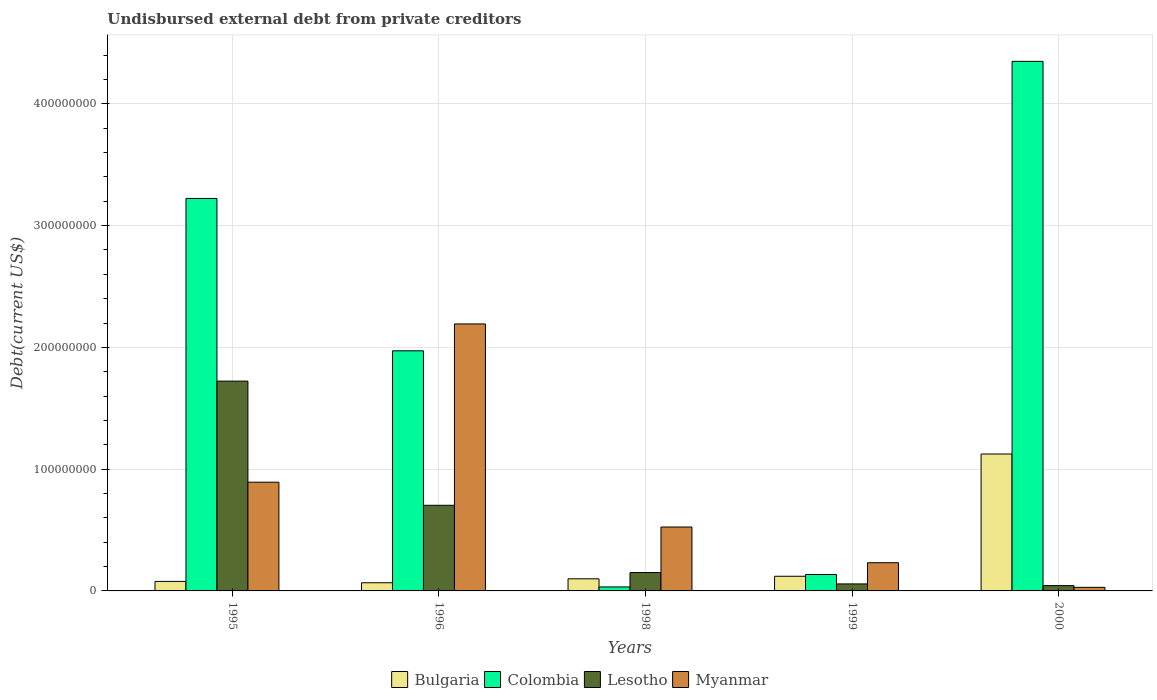How many groups of bars are there?
Your answer should be compact. 5. How many bars are there on the 3rd tick from the right?
Make the answer very short. 4. In how many cases, is the number of bars for a given year not equal to the number of legend labels?
Offer a terse response. 0. What is the total debt in Myanmar in 1996?
Offer a very short reply. 2.19e+08. Across all years, what is the maximum total debt in Bulgaria?
Offer a very short reply. 1.12e+08. Across all years, what is the minimum total debt in Bulgaria?
Ensure brevity in your answer.  6.71e+06. In which year was the total debt in Colombia maximum?
Your answer should be very brief. 2000. In which year was the total debt in Lesotho minimum?
Give a very brief answer. 2000. What is the total total debt in Myanmar in the graph?
Give a very brief answer. 3.87e+08. What is the difference between the total debt in Myanmar in 1996 and that in 1998?
Ensure brevity in your answer.  1.67e+08. What is the difference between the total debt in Lesotho in 1999 and the total debt in Colombia in 1995?
Offer a very short reply. -3.17e+08. What is the average total debt in Lesotho per year?
Your response must be concise. 5.36e+07. In the year 2000, what is the difference between the total debt in Bulgaria and total debt in Myanmar?
Give a very brief answer. 1.10e+08. In how many years, is the total debt in Lesotho greater than 280000000 US$?
Offer a terse response. 0. What is the ratio of the total debt in Colombia in 1995 to that in 2000?
Keep it short and to the point. 0.74. Is the total debt in Myanmar in 1995 less than that in 1999?
Your answer should be very brief. No. What is the difference between the highest and the second highest total debt in Bulgaria?
Make the answer very short. 1.00e+08. What is the difference between the highest and the lowest total debt in Colombia?
Your answer should be very brief. 4.32e+08. In how many years, is the total debt in Colombia greater than the average total debt in Colombia taken over all years?
Ensure brevity in your answer.  3. Is it the case that in every year, the sum of the total debt in Lesotho and total debt in Bulgaria is greater than the sum of total debt in Colombia and total debt in Myanmar?
Offer a very short reply. No. What does the 1st bar from the left in 1999 represents?
Provide a short and direct response. Bulgaria. Is it the case that in every year, the sum of the total debt in Bulgaria and total debt in Myanmar is greater than the total debt in Colombia?
Provide a short and direct response. No. Are all the bars in the graph horizontal?
Your response must be concise. No. How many years are there in the graph?
Offer a very short reply. 5. Does the graph contain any zero values?
Offer a very short reply. No. Does the graph contain grids?
Your answer should be very brief. Yes. What is the title of the graph?
Give a very brief answer. Undisbursed external debt from private creditors. What is the label or title of the Y-axis?
Ensure brevity in your answer.  Debt(current US$). What is the Debt(current US$) in Bulgaria in 1995?
Provide a short and direct response. 7.82e+06. What is the Debt(current US$) in Colombia in 1995?
Provide a short and direct response. 3.22e+08. What is the Debt(current US$) in Lesotho in 1995?
Your answer should be compact. 1.72e+08. What is the Debt(current US$) of Myanmar in 1995?
Your answer should be compact. 8.93e+07. What is the Debt(current US$) of Bulgaria in 1996?
Your response must be concise. 6.71e+06. What is the Debt(current US$) of Colombia in 1996?
Offer a terse response. 1.97e+08. What is the Debt(current US$) of Lesotho in 1996?
Offer a terse response. 7.03e+07. What is the Debt(current US$) of Myanmar in 1996?
Your answer should be compact. 2.19e+08. What is the Debt(current US$) in Bulgaria in 1998?
Ensure brevity in your answer.  9.95e+06. What is the Debt(current US$) of Colombia in 1998?
Give a very brief answer. 3.28e+06. What is the Debt(current US$) in Lesotho in 1998?
Offer a very short reply. 1.51e+07. What is the Debt(current US$) in Myanmar in 1998?
Provide a short and direct response. 5.25e+07. What is the Debt(current US$) of Bulgaria in 1999?
Keep it short and to the point. 1.20e+07. What is the Debt(current US$) of Colombia in 1999?
Your answer should be very brief. 1.35e+07. What is the Debt(current US$) in Lesotho in 1999?
Your answer should be compact. 5.75e+06. What is the Debt(current US$) of Myanmar in 1999?
Offer a very short reply. 2.32e+07. What is the Debt(current US$) in Bulgaria in 2000?
Offer a very short reply. 1.12e+08. What is the Debt(current US$) in Colombia in 2000?
Offer a very short reply. 4.35e+08. What is the Debt(current US$) of Lesotho in 2000?
Your answer should be compact. 4.36e+06. What is the Debt(current US$) in Myanmar in 2000?
Provide a succinct answer. 2.94e+06. Across all years, what is the maximum Debt(current US$) in Bulgaria?
Your answer should be very brief. 1.12e+08. Across all years, what is the maximum Debt(current US$) of Colombia?
Make the answer very short. 4.35e+08. Across all years, what is the maximum Debt(current US$) of Lesotho?
Offer a very short reply. 1.72e+08. Across all years, what is the maximum Debt(current US$) of Myanmar?
Offer a very short reply. 2.19e+08. Across all years, what is the minimum Debt(current US$) in Bulgaria?
Your answer should be very brief. 6.71e+06. Across all years, what is the minimum Debt(current US$) in Colombia?
Offer a very short reply. 3.28e+06. Across all years, what is the minimum Debt(current US$) in Lesotho?
Keep it short and to the point. 4.36e+06. Across all years, what is the minimum Debt(current US$) of Myanmar?
Your answer should be very brief. 2.94e+06. What is the total Debt(current US$) in Bulgaria in the graph?
Your answer should be very brief. 1.49e+08. What is the total Debt(current US$) of Colombia in the graph?
Offer a terse response. 9.71e+08. What is the total Debt(current US$) in Lesotho in the graph?
Keep it short and to the point. 2.68e+08. What is the total Debt(current US$) in Myanmar in the graph?
Give a very brief answer. 3.87e+08. What is the difference between the Debt(current US$) of Bulgaria in 1995 and that in 1996?
Provide a succinct answer. 1.11e+06. What is the difference between the Debt(current US$) of Colombia in 1995 and that in 1996?
Provide a short and direct response. 1.25e+08. What is the difference between the Debt(current US$) in Lesotho in 1995 and that in 1996?
Keep it short and to the point. 1.02e+08. What is the difference between the Debt(current US$) of Myanmar in 1995 and that in 1996?
Make the answer very short. -1.30e+08. What is the difference between the Debt(current US$) in Bulgaria in 1995 and that in 1998?
Your answer should be compact. -2.14e+06. What is the difference between the Debt(current US$) of Colombia in 1995 and that in 1998?
Your answer should be compact. 3.19e+08. What is the difference between the Debt(current US$) in Lesotho in 1995 and that in 1998?
Your answer should be compact. 1.57e+08. What is the difference between the Debt(current US$) of Myanmar in 1995 and that in 1998?
Keep it short and to the point. 3.68e+07. What is the difference between the Debt(current US$) in Bulgaria in 1995 and that in 1999?
Keep it short and to the point. -4.23e+06. What is the difference between the Debt(current US$) of Colombia in 1995 and that in 1999?
Provide a short and direct response. 3.09e+08. What is the difference between the Debt(current US$) in Lesotho in 1995 and that in 1999?
Ensure brevity in your answer.  1.67e+08. What is the difference between the Debt(current US$) of Myanmar in 1995 and that in 1999?
Give a very brief answer. 6.61e+07. What is the difference between the Debt(current US$) in Bulgaria in 1995 and that in 2000?
Your answer should be compact. -1.05e+08. What is the difference between the Debt(current US$) in Colombia in 1995 and that in 2000?
Provide a short and direct response. -1.13e+08. What is the difference between the Debt(current US$) of Lesotho in 1995 and that in 2000?
Your answer should be compact. 1.68e+08. What is the difference between the Debt(current US$) in Myanmar in 1995 and that in 2000?
Give a very brief answer. 8.64e+07. What is the difference between the Debt(current US$) in Bulgaria in 1996 and that in 1998?
Your answer should be very brief. -3.25e+06. What is the difference between the Debt(current US$) of Colombia in 1996 and that in 1998?
Give a very brief answer. 1.94e+08. What is the difference between the Debt(current US$) in Lesotho in 1996 and that in 1998?
Offer a very short reply. 5.52e+07. What is the difference between the Debt(current US$) in Myanmar in 1996 and that in 1998?
Give a very brief answer. 1.67e+08. What is the difference between the Debt(current US$) of Bulgaria in 1996 and that in 1999?
Keep it short and to the point. -5.34e+06. What is the difference between the Debt(current US$) of Colombia in 1996 and that in 1999?
Provide a short and direct response. 1.84e+08. What is the difference between the Debt(current US$) in Lesotho in 1996 and that in 1999?
Your answer should be very brief. 6.46e+07. What is the difference between the Debt(current US$) in Myanmar in 1996 and that in 1999?
Offer a very short reply. 1.96e+08. What is the difference between the Debt(current US$) in Bulgaria in 1996 and that in 2000?
Offer a very short reply. -1.06e+08. What is the difference between the Debt(current US$) in Colombia in 1996 and that in 2000?
Offer a very short reply. -2.38e+08. What is the difference between the Debt(current US$) of Lesotho in 1996 and that in 2000?
Your response must be concise. 6.60e+07. What is the difference between the Debt(current US$) in Myanmar in 1996 and that in 2000?
Give a very brief answer. 2.16e+08. What is the difference between the Debt(current US$) in Bulgaria in 1998 and that in 1999?
Your response must be concise. -2.09e+06. What is the difference between the Debt(current US$) in Colombia in 1998 and that in 1999?
Offer a very short reply. -1.02e+07. What is the difference between the Debt(current US$) in Lesotho in 1998 and that in 1999?
Ensure brevity in your answer.  9.35e+06. What is the difference between the Debt(current US$) of Myanmar in 1998 and that in 1999?
Provide a succinct answer. 2.93e+07. What is the difference between the Debt(current US$) of Bulgaria in 1998 and that in 2000?
Give a very brief answer. -1.02e+08. What is the difference between the Debt(current US$) of Colombia in 1998 and that in 2000?
Offer a terse response. -4.32e+08. What is the difference between the Debt(current US$) of Lesotho in 1998 and that in 2000?
Give a very brief answer. 1.07e+07. What is the difference between the Debt(current US$) of Myanmar in 1998 and that in 2000?
Offer a very short reply. 4.96e+07. What is the difference between the Debt(current US$) of Bulgaria in 1999 and that in 2000?
Provide a short and direct response. -1.00e+08. What is the difference between the Debt(current US$) in Colombia in 1999 and that in 2000?
Give a very brief answer. -4.21e+08. What is the difference between the Debt(current US$) in Lesotho in 1999 and that in 2000?
Offer a terse response. 1.39e+06. What is the difference between the Debt(current US$) of Myanmar in 1999 and that in 2000?
Make the answer very short. 2.02e+07. What is the difference between the Debt(current US$) in Bulgaria in 1995 and the Debt(current US$) in Colombia in 1996?
Provide a succinct answer. -1.89e+08. What is the difference between the Debt(current US$) of Bulgaria in 1995 and the Debt(current US$) of Lesotho in 1996?
Provide a short and direct response. -6.25e+07. What is the difference between the Debt(current US$) of Bulgaria in 1995 and the Debt(current US$) of Myanmar in 1996?
Provide a short and direct response. -2.11e+08. What is the difference between the Debt(current US$) of Colombia in 1995 and the Debt(current US$) of Lesotho in 1996?
Offer a very short reply. 2.52e+08. What is the difference between the Debt(current US$) of Colombia in 1995 and the Debt(current US$) of Myanmar in 1996?
Your response must be concise. 1.03e+08. What is the difference between the Debt(current US$) in Lesotho in 1995 and the Debt(current US$) in Myanmar in 1996?
Keep it short and to the point. -4.70e+07. What is the difference between the Debt(current US$) of Bulgaria in 1995 and the Debt(current US$) of Colombia in 1998?
Your response must be concise. 4.53e+06. What is the difference between the Debt(current US$) of Bulgaria in 1995 and the Debt(current US$) of Lesotho in 1998?
Ensure brevity in your answer.  -7.29e+06. What is the difference between the Debt(current US$) in Bulgaria in 1995 and the Debt(current US$) in Myanmar in 1998?
Provide a short and direct response. -4.47e+07. What is the difference between the Debt(current US$) of Colombia in 1995 and the Debt(current US$) of Lesotho in 1998?
Your answer should be very brief. 3.07e+08. What is the difference between the Debt(current US$) of Colombia in 1995 and the Debt(current US$) of Myanmar in 1998?
Ensure brevity in your answer.  2.70e+08. What is the difference between the Debt(current US$) in Lesotho in 1995 and the Debt(current US$) in Myanmar in 1998?
Ensure brevity in your answer.  1.20e+08. What is the difference between the Debt(current US$) of Bulgaria in 1995 and the Debt(current US$) of Colombia in 1999?
Give a very brief answer. -5.66e+06. What is the difference between the Debt(current US$) in Bulgaria in 1995 and the Debt(current US$) in Lesotho in 1999?
Ensure brevity in your answer.  2.06e+06. What is the difference between the Debt(current US$) in Bulgaria in 1995 and the Debt(current US$) in Myanmar in 1999?
Your answer should be very brief. -1.53e+07. What is the difference between the Debt(current US$) of Colombia in 1995 and the Debt(current US$) of Lesotho in 1999?
Your answer should be compact. 3.17e+08. What is the difference between the Debt(current US$) of Colombia in 1995 and the Debt(current US$) of Myanmar in 1999?
Keep it short and to the point. 2.99e+08. What is the difference between the Debt(current US$) of Lesotho in 1995 and the Debt(current US$) of Myanmar in 1999?
Your response must be concise. 1.49e+08. What is the difference between the Debt(current US$) in Bulgaria in 1995 and the Debt(current US$) in Colombia in 2000?
Your answer should be very brief. -4.27e+08. What is the difference between the Debt(current US$) in Bulgaria in 1995 and the Debt(current US$) in Lesotho in 2000?
Give a very brief answer. 3.46e+06. What is the difference between the Debt(current US$) of Bulgaria in 1995 and the Debt(current US$) of Myanmar in 2000?
Ensure brevity in your answer.  4.88e+06. What is the difference between the Debt(current US$) of Colombia in 1995 and the Debt(current US$) of Lesotho in 2000?
Offer a terse response. 3.18e+08. What is the difference between the Debt(current US$) in Colombia in 1995 and the Debt(current US$) in Myanmar in 2000?
Offer a terse response. 3.19e+08. What is the difference between the Debt(current US$) in Lesotho in 1995 and the Debt(current US$) in Myanmar in 2000?
Ensure brevity in your answer.  1.69e+08. What is the difference between the Debt(current US$) of Bulgaria in 1996 and the Debt(current US$) of Colombia in 1998?
Ensure brevity in your answer.  3.43e+06. What is the difference between the Debt(current US$) in Bulgaria in 1996 and the Debt(current US$) in Lesotho in 1998?
Your answer should be compact. -8.40e+06. What is the difference between the Debt(current US$) in Bulgaria in 1996 and the Debt(current US$) in Myanmar in 1998?
Your response must be concise. -4.58e+07. What is the difference between the Debt(current US$) in Colombia in 1996 and the Debt(current US$) in Lesotho in 1998?
Provide a short and direct response. 1.82e+08. What is the difference between the Debt(current US$) of Colombia in 1996 and the Debt(current US$) of Myanmar in 1998?
Offer a terse response. 1.45e+08. What is the difference between the Debt(current US$) of Lesotho in 1996 and the Debt(current US$) of Myanmar in 1998?
Offer a very short reply. 1.78e+07. What is the difference between the Debt(current US$) of Bulgaria in 1996 and the Debt(current US$) of Colombia in 1999?
Your answer should be very brief. -6.77e+06. What is the difference between the Debt(current US$) of Bulgaria in 1996 and the Debt(current US$) of Lesotho in 1999?
Provide a succinct answer. 9.55e+05. What is the difference between the Debt(current US$) in Bulgaria in 1996 and the Debt(current US$) in Myanmar in 1999?
Your answer should be very brief. -1.65e+07. What is the difference between the Debt(current US$) of Colombia in 1996 and the Debt(current US$) of Lesotho in 1999?
Keep it short and to the point. 1.91e+08. What is the difference between the Debt(current US$) in Colombia in 1996 and the Debt(current US$) in Myanmar in 1999?
Ensure brevity in your answer.  1.74e+08. What is the difference between the Debt(current US$) of Lesotho in 1996 and the Debt(current US$) of Myanmar in 1999?
Offer a very short reply. 4.72e+07. What is the difference between the Debt(current US$) in Bulgaria in 1996 and the Debt(current US$) in Colombia in 2000?
Give a very brief answer. -4.28e+08. What is the difference between the Debt(current US$) of Bulgaria in 1996 and the Debt(current US$) of Lesotho in 2000?
Your response must be concise. 2.35e+06. What is the difference between the Debt(current US$) of Bulgaria in 1996 and the Debt(current US$) of Myanmar in 2000?
Your answer should be very brief. 3.77e+06. What is the difference between the Debt(current US$) in Colombia in 1996 and the Debt(current US$) in Lesotho in 2000?
Keep it short and to the point. 1.93e+08. What is the difference between the Debt(current US$) of Colombia in 1996 and the Debt(current US$) of Myanmar in 2000?
Provide a short and direct response. 1.94e+08. What is the difference between the Debt(current US$) in Lesotho in 1996 and the Debt(current US$) in Myanmar in 2000?
Provide a short and direct response. 6.74e+07. What is the difference between the Debt(current US$) in Bulgaria in 1998 and the Debt(current US$) in Colombia in 1999?
Offer a terse response. -3.53e+06. What is the difference between the Debt(current US$) of Bulgaria in 1998 and the Debt(current US$) of Lesotho in 1999?
Provide a short and direct response. 4.20e+06. What is the difference between the Debt(current US$) in Bulgaria in 1998 and the Debt(current US$) in Myanmar in 1999?
Ensure brevity in your answer.  -1.32e+07. What is the difference between the Debt(current US$) of Colombia in 1998 and the Debt(current US$) of Lesotho in 1999?
Offer a terse response. -2.47e+06. What is the difference between the Debt(current US$) of Colombia in 1998 and the Debt(current US$) of Myanmar in 1999?
Make the answer very short. -1.99e+07. What is the difference between the Debt(current US$) of Lesotho in 1998 and the Debt(current US$) of Myanmar in 1999?
Your answer should be compact. -8.06e+06. What is the difference between the Debt(current US$) of Bulgaria in 1998 and the Debt(current US$) of Colombia in 2000?
Make the answer very short. -4.25e+08. What is the difference between the Debt(current US$) of Bulgaria in 1998 and the Debt(current US$) of Lesotho in 2000?
Offer a very short reply. 5.59e+06. What is the difference between the Debt(current US$) of Bulgaria in 1998 and the Debt(current US$) of Myanmar in 2000?
Keep it short and to the point. 7.01e+06. What is the difference between the Debt(current US$) in Colombia in 1998 and the Debt(current US$) in Lesotho in 2000?
Give a very brief answer. -1.08e+06. What is the difference between the Debt(current US$) of Colombia in 1998 and the Debt(current US$) of Myanmar in 2000?
Keep it short and to the point. 3.42e+05. What is the difference between the Debt(current US$) in Lesotho in 1998 and the Debt(current US$) in Myanmar in 2000?
Keep it short and to the point. 1.22e+07. What is the difference between the Debt(current US$) in Bulgaria in 1999 and the Debt(current US$) in Colombia in 2000?
Offer a very short reply. -4.23e+08. What is the difference between the Debt(current US$) in Bulgaria in 1999 and the Debt(current US$) in Lesotho in 2000?
Offer a terse response. 7.69e+06. What is the difference between the Debt(current US$) of Bulgaria in 1999 and the Debt(current US$) of Myanmar in 2000?
Make the answer very short. 9.11e+06. What is the difference between the Debt(current US$) in Colombia in 1999 and the Debt(current US$) in Lesotho in 2000?
Offer a very short reply. 9.12e+06. What is the difference between the Debt(current US$) of Colombia in 1999 and the Debt(current US$) of Myanmar in 2000?
Provide a short and direct response. 1.05e+07. What is the difference between the Debt(current US$) of Lesotho in 1999 and the Debt(current US$) of Myanmar in 2000?
Make the answer very short. 2.81e+06. What is the average Debt(current US$) in Bulgaria per year?
Provide a succinct answer. 2.98e+07. What is the average Debt(current US$) in Colombia per year?
Offer a very short reply. 1.94e+08. What is the average Debt(current US$) of Lesotho per year?
Your response must be concise. 5.36e+07. What is the average Debt(current US$) of Myanmar per year?
Provide a succinct answer. 7.74e+07. In the year 1995, what is the difference between the Debt(current US$) of Bulgaria and Debt(current US$) of Colombia?
Your answer should be very brief. -3.15e+08. In the year 1995, what is the difference between the Debt(current US$) in Bulgaria and Debt(current US$) in Lesotho?
Offer a terse response. -1.64e+08. In the year 1995, what is the difference between the Debt(current US$) of Bulgaria and Debt(current US$) of Myanmar?
Give a very brief answer. -8.15e+07. In the year 1995, what is the difference between the Debt(current US$) of Colombia and Debt(current US$) of Lesotho?
Make the answer very short. 1.50e+08. In the year 1995, what is the difference between the Debt(current US$) in Colombia and Debt(current US$) in Myanmar?
Offer a very short reply. 2.33e+08. In the year 1995, what is the difference between the Debt(current US$) in Lesotho and Debt(current US$) in Myanmar?
Make the answer very short. 8.30e+07. In the year 1996, what is the difference between the Debt(current US$) in Bulgaria and Debt(current US$) in Colombia?
Provide a succinct answer. -1.90e+08. In the year 1996, what is the difference between the Debt(current US$) of Bulgaria and Debt(current US$) of Lesotho?
Make the answer very short. -6.36e+07. In the year 1996, what is the difference between the Debt(current US$) of Bulgaria and Debt(current US$) of Myanmar?
Keep it short and to the point. -2.13e+08. In the year 1996, what is the difference between the Debt(current US$) in Colombia and Debt(current US$) in Lesotho?
Your answer should be very brief. 1.27e+08. In the year 1996, what is the difference between the Debt(current US$) in Colombia and Debt(current US$) in Myanmar?
Provide a short and direct response. -2.21e+07. In the year 1996, what is the difference between the Debt(current US$) of Lesotho and Debt(current US$) of Myanmar?
Give a very brief answer. -1.49e+08. In the year 1998, what is the difference between the Debt(current US$) of Bulgaria and Debt(current US$) of Colombia?
Your response must be concise. 6.67e+06. In the year 1998, what is the difference between the Debt(current US$) of Bulgaria and Debt(current US$) of Lesotho?
Give a very brief answer. -5.15e+06. In the year 1998, what is the difference between the Debt(current US$) in Bulgaria and Debt(current US$) in Myanmar?
Provide a succinct answer. -4.25e+07. In the year 1998, what is the difference between the Debt(current US$) of Colombia and Debt(current US$) of Lesotho?
Provide a short and direct response. -1.18e+07. In the year 1998, what is the difference between the Debt(current US$) of Colombia and Debt(current US$) of Myanmar?
Keep it short and to the point. -4.92e+07. In the year 1998, what is the difference between the Debt(current US$) in Lesotho and Debt(current US$) in Myanmar?
Make the answer very short. -3.74e+07. In the year 1999, what is the difference between the Debt(current US$) of Bulgaria and Debt(current US$) of Colombia?
Make the answer very short. -1.43e+06. In the year 1999, what is the difference between the Debt(current US$) in Bulgaria and Debt(current US$) in Lesotho?
Provide a succinct answer. 6.29e+06. In the year 1999, what is the difference between the Debt(current US$) of Bulgaria and Debt(current US$) of Myanmar?
Offer a very short reply. -1.11e+07. In the year 1999, what is the difference between the Debt(current US$) in Colombia and Debt(current US$) in Lesotho?
Ensure brevity in your answer.  7.73e+06. In the year 1999, what is the difference between the Debt(current US$) of Colombia and Debt(current US$) of Myanmar?
Provide a short and direct response. -9.68e+06. In the year 1999, what is the difference between the Debt(current US$) of Lesotho and Debt(current US$) of Myanmar?
Your response must be concise. -1.74e+07. In the year 2000, what is the difference between the Debt(current US$) of Bulgaria and Debt(current US$) of Colombia?
Your answer should be very brief. -3.22e+08. In the year 2000, what is the difference between the Debt(current US$) in Bulgaria and Debt(current US$) in Lesotho?
Make the answer very short. 1.08e+08. In the year 2000, what is the difference between the Debt(current US$) of Bulgaria and Debt(current US$) of Myanmar?
Keep it short and to the point. 1.10e+08. In the year 2000, what is the difference between the Debt(current US$) of Colombia and Debt(current US$) of Lesotho?
Provide a succinct answer. 4.31e+08. In the year 2000, what is the difference between the Debt(current US$) in Colombia and Debt(current US$) in Myanmar?
Provide a short and direct response. 4.32e+08. In the year 2000, what is the difference between the Debt(current US$) in Lesotho and Debt(current US$) in Myanmar?
Offer a terse response. 1.42e+06. What is the ratio of the Debt(current US$) in Bulgaria in 1995 to that in 1996?
Make the answer very short. 1.17. What is the ratio of the Debt(current US$) in Colombia in 1995 to that in 1996?
Your answer should be very brief. 1.63. What is the ratio of the Debt(current US$) of Lesotho in 1995 to that in 1996?
Your answer should be very brief. 2.45. What is the ratio of the Debt(current US$) in Myanmar in 1995 to that in 1996?
Make the answer very short. 0.41. What is the ratio of the Debt(current US$) in Bulgaria in 1995 to that in 1998?
Offer a terse response. 0.79. What is the ratio of the Debt(current US$) in Colombia in 1995 to that in 1998?
Keep it short and to the point. 98.24. What is the ratio of the Debt(current US$) of Lesotho in 1995 to that in 1998?
Give a very brief answer. 11.41. What is the ratio of the Debt(current US$) of Myanmar in 1995 to that in 1998?
Make the answer very short. 1.7. What is the ratio of the Debt(current US$) of Bulgaria in 1995 to that in 1999?
Provide a short and direct response. 0.65. What is the ratio of the Debt(current US$) in Colombia in 1995 to that in 1999?
Your answer should be very brief. 23.91. What is the ratio of the Debt(current US$) of Lesotho in 1995 to that in 1999?
Provide a short and direct response. 29.96. What is the ratio of the Debt(current US$) of Myanmar in 1995 to that in 1999?
Offer a very short reply. 3.86. What is the ratio of the Debt(current US$) in Bulgaria in 1995 to that in 2000?
Give a very brief answer. 0.07. What is the ratio of the Debt(current US$) in Colombia in 1995 to that in 2000?
Provide a succinct answer. 0.74. What is the ratio of the Debt(current US$) in Lesotho in 1995 to that in 2000?
Give a very brief answer. 39.53. What is the ratio of the Debt(current US$) of Myanmar in 1995 to that in 2000?
Make the answer very short. 30.38. What is the ratio of the Debt(current US$) in Bulgaria in 1996 to that in 1998?
Keep it short and to the point. 0.67. What is the ratio of the Debt(current US$) of Colombia in 1996 to that in 1998?
Ensure brevity in your answer.  60.1. What is the ratio of the Debt(current US$) of Lesotho in 1996 to that in 1998?
Keep it short and to the point. 4.66. What is the ratio of the Debt(current US$) of Myanmar in 1996 to that in 1998?
Provide a succinct answer. 4.18. What is the ratio of the Debt(current US$) in Bulgaria in 1996 to that in 1999?
Give a very brief answer. 0.56. What is the ratio of the Debt(current US$) of Colombia in 1996 to that in 1999?
Offer a terse response. 14.63. What is the ratio of the Debt(current US$) in Lesotho in 1996 to that in 1999?
Offer a terse response. 12.23. What is the ratio of the Debt(current US$) of Myanmar in 1996 to that in 1999?
Your response must be concise. 9.47. What is the ratio of the Debt(current US$) in Bulgaria in 1996 to that in 2000?
Make the answer very short. 0.06. What is the ratio of the Debt(current US$) of Colombia in 1996 to that in 2000?
Provide a succinct answer. 0.45. What is the ratio of the Debt(current US$) of Lesotho in 1996 to that in 2000?
Keep it short and to the point. 16.13. What is the ratio of the Debt(current US$) of Myanmar in 1996 to that in 2000?
Make the answer very short. 74.61. What is the ratio of the Debt(current US$) in Bulgaria in 1998 to that in 1999?
Offer a terse response. 0.83. What is the ratio of the Debt(current US$) in Colombia in 1998 to that in 1999?
Make the answer very short. 0.24. What is the ratio of the Debt(current US$) in Lesotho in 1998 to that in 1999?
Keep it short and to the point. 2.63. What is the ratio of the Debt(current US$) in Myanmar in 1998 to that in 1999?
Your response must be concise. 2.27. What is the ratio of the Debt(current US$) of Bulgaria in 1998 to that in 2000?
Provide a succinct answer. 0.09. What is the ratio of the Debt(current US$) in Colombia in 1998 to that in 2000?
Keep it short and to the point. 0.01. What is the ratio of the Debt(current US$) in Lesotho in 1998 to that in 2000?
Provide a succinct answer. 3.46. What is the ratio of the Debt(current US$) in Myanmar in 1998 to that in 2000?
Make the answer very short. 17.86. What is the ratio of the Debt(current US$) in Bulgaria in 1999 to that in 2000?
Provide a short and direct response. 0.11. What is the ratio of the Debt(current US$) of Colombia in 1999 to that in 2000?
Your answer should be compact. 0.03. What is the ratio of the Debt(current US$) in Lesotho in 1999 to that in 2000?
Your answer should be very brief. 1.32. What is the ratio of the Debt(current US$) of Myanmar in 1999 to that in 2000?
Your answer should be compact. 7.88. What is the difference between the highest and the second highest Debt(current US$) in Bulgaria?
Your response must be concise. 1.00e+08. What is the difference between the highest and the second highest Debt(current US$) of Colombia?
Keep it short and to the point. 1.13e+08. What is the difference between the highest and the second highest Debt(current US$) in Lesotho?
Provide a short and direct response. 1.02e+08. What is the difference between the highest and the second highest Debt(current US$) in Myanmar?
Ensure brevity in your answer.  1.30e+08. What is the difference between the highest and the lowest Debt(current US$) of Bulgaria?
Your answer should be very brief. 1.06e+08. What is the difference between the highest and the lowest Debt(current US$) of Colombia?
Your response must be concise. 4.32e+08. What is the difference between the highest and the lowest Debt(current US$) of Lesotho?
Offer a very short reply. 1.68e+08. What is the difference between the highest and the lowest Debt(current US$) of Myanmar?
Your answer should be very brief. 2.16e+08. 